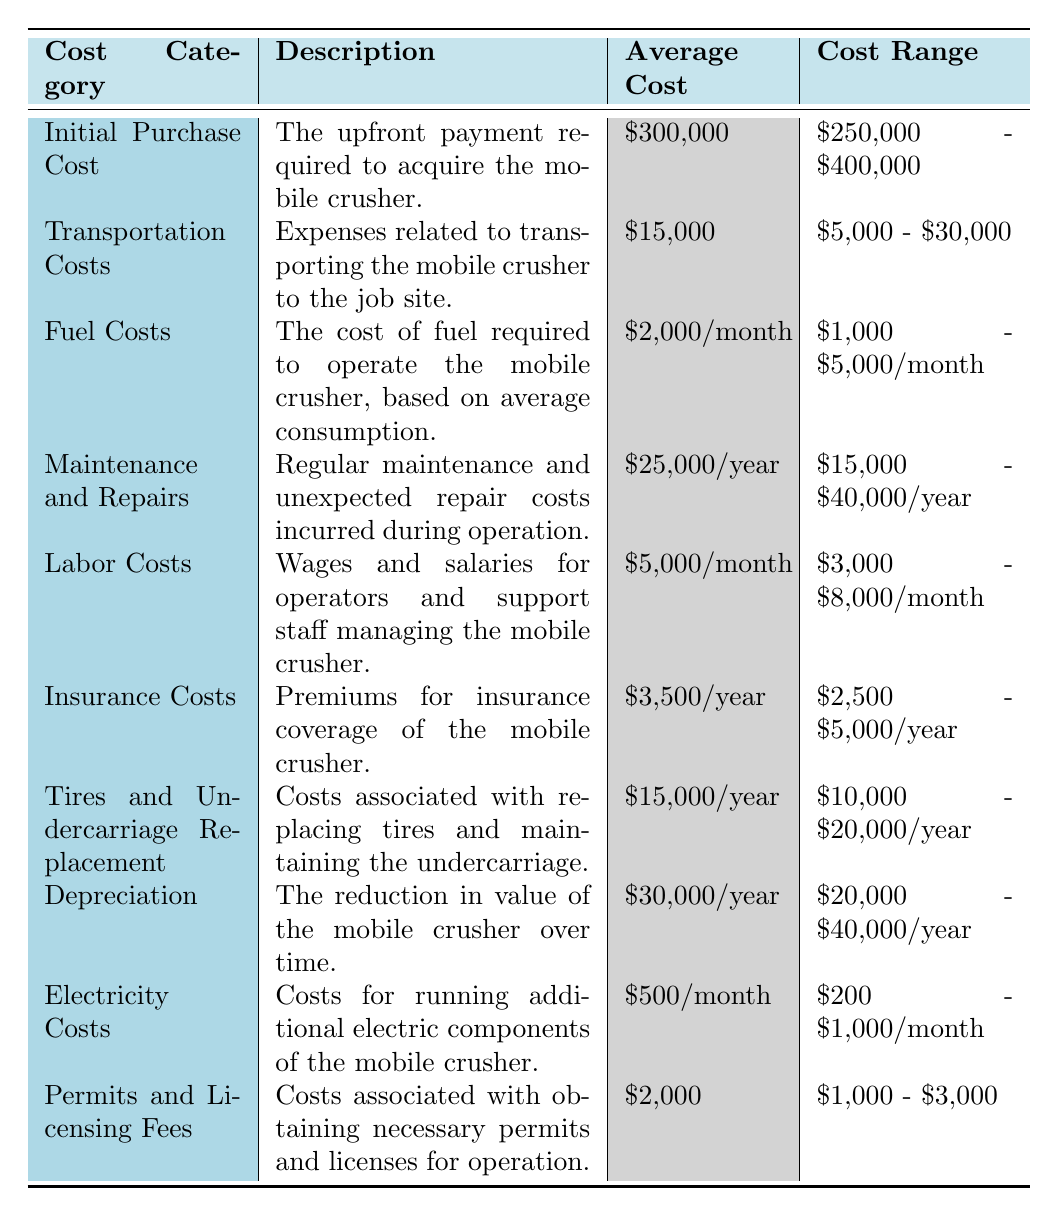What is the average cost of the "Initial Purchase Cost"? The average cost listed for the "Initial Purchase Cost" is \$300,000 as per the table.
Answer: \$300,000 What is the range of "Transportation Costs"? The table specifies that the transportation costs range from \$5,000 to \$30,000.
Answer: \$5,000 - \$30,000 How much do "Fuel Costs" average per month? According to the table, the average fuel costs are \$2,000 per month.
Answer: \$2,000/month What are the minimum and maximum costs for "Maintenance and Repairs"? The minimum cost for maintenance and repairs is \$15,000 and the maximum is \$40,000, according to the table.
Answer: \$15,000 - \$40,000 Are the "Insurance Costs" higher on average than the "Electricity Costs"? The average insurance costs are \$3,500 per year, and the electricity costs average \$500 per month (which is \$6,000 per year), so insurance costs are lower.
Answer: No What is the total annual cost of "Labor Costs" if averaged out? The average labor cost per month is \$5,000. Over a year (12 months), that amounts to \$5,000 * 12 = \$60,000.
Answer: \$60,000/year If we sum the "Average Cost" of all categories, what is the total? The total average cost is calculated by adding up all the average costs: \$300,000 (purchase) + \$15,000 (transport) + \$24,000 (fuel) + \$25,000 (maintenance) + \$60,000 (labor) + \$3,500 (insurance) + \$15,000 (tires) + \$30,000 (depreciation) + \$6,000 (electricity) + \$2,000 (permits) = \$480,500.
Answer: \$480,500 What is the average "Depreciation" cost per year compared to "Tires and Undercarriage Replacement"? The average depreciation cost is \$30,000 per year, whereas tires and undercarriage replacement averages \$15,000 per year. Thus, depreciation costs are higher.
Answer: Yes, Depreciation is higher What is the total difference between the maximum and minimum "Fuel Costs"? The maximum fuel cost is \$5,000 and the minimum is \$1,000, so the difference is \$5,000 - \$1,000 = \$4,000.
Answer: \$4,000 If you purchase the mobile crusher at the maximum price, what would be the total cost including minimum "Transportation Costs"? The maximum purchase cost is \$400,000 and the minimum transportation cost is \$5,000, so total equals \$400,000 + \$5,000 = \$405,000.
Answer: \$405,000 